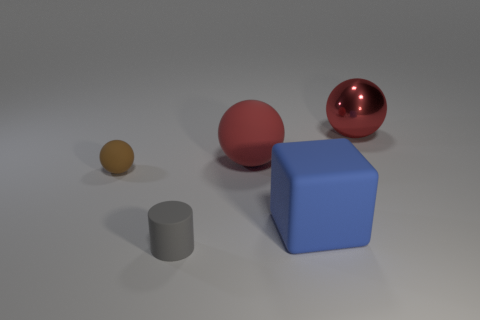Add 3 red matte spheres. How many objects exist? 8 Subtract all balls. How many objects are left? 2 Add 5 small brown things. How many small brown things are left? 6 Add 5 brown rubber objects. How many brown rubber objects exist? 6 Subtract 0 green cylinders. How many objects are left? 5 Subtract all yellow metallic cylinders. Subtract all large blue cubes. How many objects are left? 4 